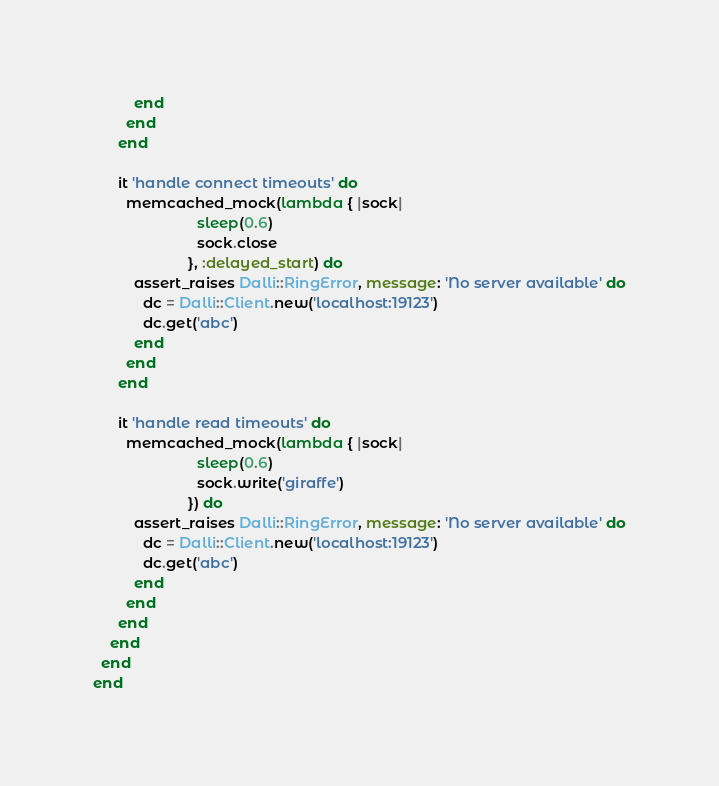<code> <loc_0><loc_0><loc_500><loc_500><_Ruby_>          end
        end
      end

      it 'handle connect timeouts' do
        memcached_mock(lambda { |sock|
                         sleep(0.6)
                         sock.close
                       }, :delayed_start) do
          assert_raises Dalli::RingError, message: 'No server available' do
            dc = Dalli::Client.new('localhost:19123')
            dc.get('abc')
          end
        end
      end

      it 'handle read timeouts' do
        memcached_mock(lambda { |sock|
                         sleep(0.6)
                         sock.write('giraffe')
                       }) do
          assert_raises Dalli::RingError, message: 'No server available' do
            dc = Dalli::Client.new('localhost:19123')
            dc.get('abc')
          end
        end
      end
    end
  end
end
</code> 